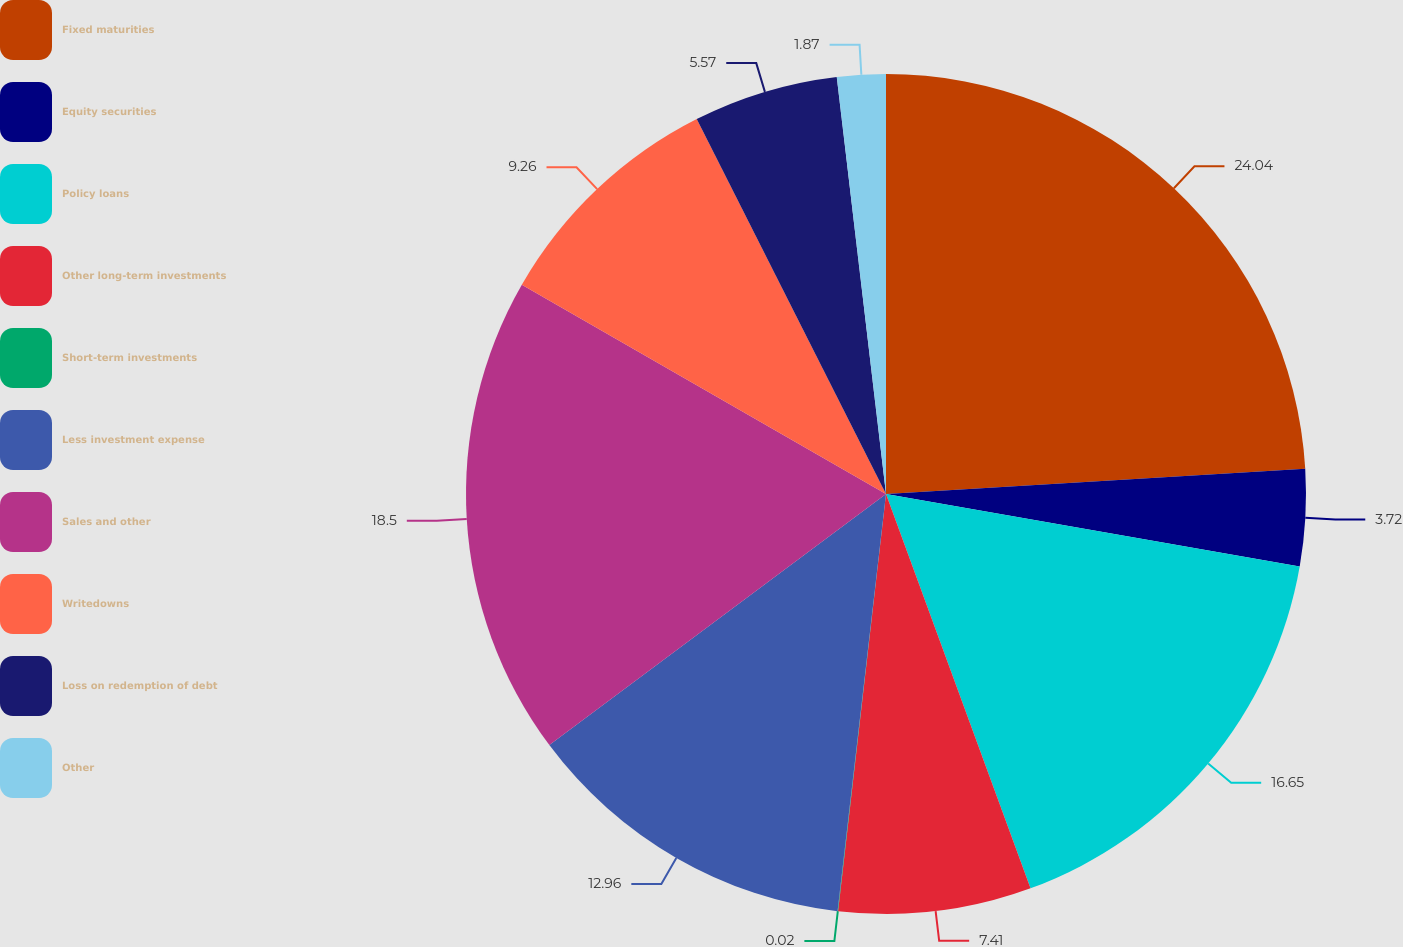Convert chart to OTSL. <chart><loc_0><loc_0><loc_500><loc_500><pie_chart><fcel>Fixed maturities<fcel>Equity securities<fcel>Policy loans<fcel>Other long-term investments<fcel>Short-term investments<fcel>Less investment expense<fcel>Sales and other<fcel>Writedowns<fcel>Loss on redemption of debt<fcel>Other<nl><fcel>24.04%<fcel>3.72%<fcel>16.65%<fcel>7.41%<fcel>0.02%<fcel>12.96%<fcel>18.5%<fcel>9.26%<fcel>5.57%<fcel>1.87%<nl></chart> 